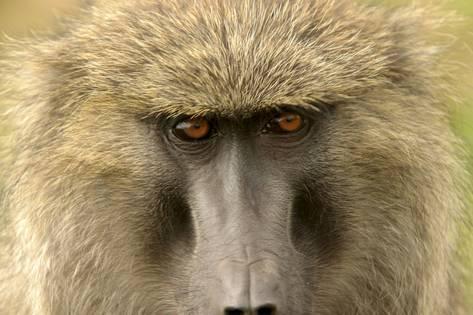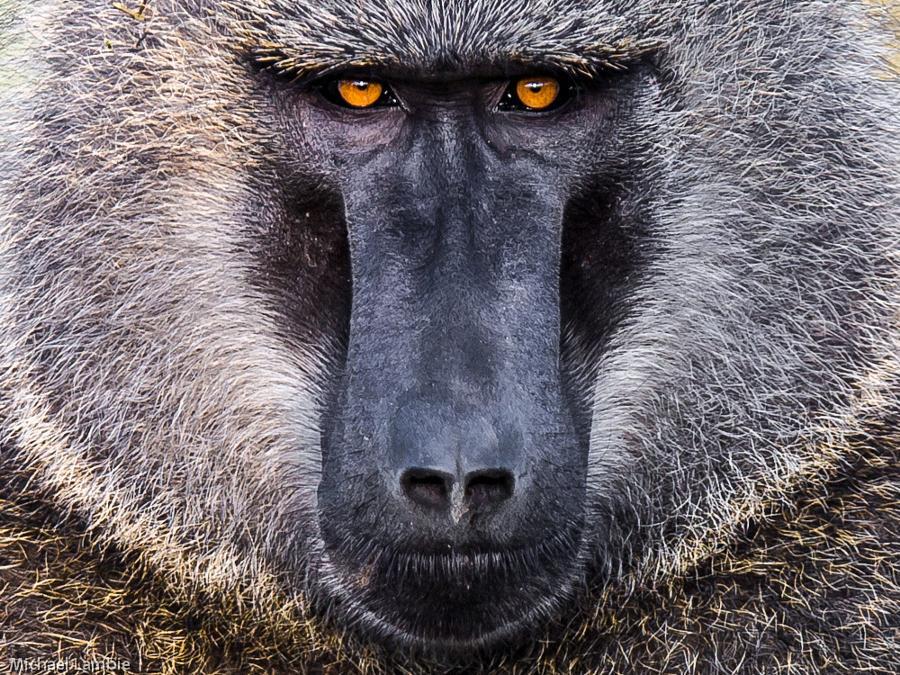The first image is the image on the left, the second image is the image on the right. For the images displayed, is the sentence "In one of the images, the animal's mouth is open as it bears its teeth" factually correct? Answer yes or no. No. 